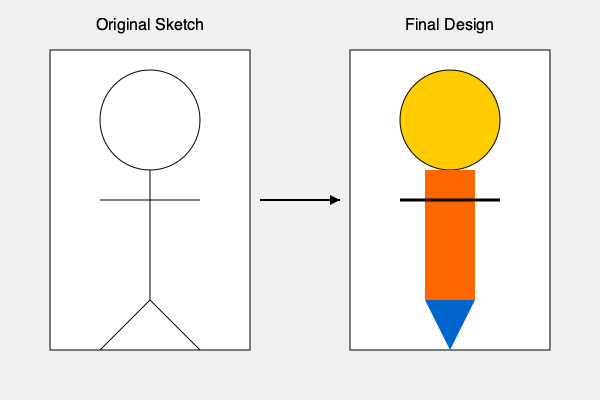In the character design evolution of FLCL, what significant changes can be observed between the original sketch and the final design of Haruko Haruhara's iconic Rickenbacker bass guitar? To answer this question, let's analyze the character design evolution of Haruko's Rickenbacker bass guitar in FLCL:

1. Shape: In the original sketch, the bass guitar is represented by a simple straight line. In the final design, it has evolved into a more defined rectangular shape with a distinct body.

2. Details: The original sketch lacks specific details, whereas the final design shows more intricate features:
   a. The body of the bass is colored orange (#ff6600), representing its iconic look.
   b. The headstock is now visible, colored blue (#0066cc), adding to the instrument's unique appearance.

3. Dimension: The original sketch is flat and two-dimensional. The final design gives a sense of depth and three-dimensionality to the bass guitar.

4. Proportion: In the final design, the bass guitar's size is more pronounced relative to Haruko's body, emphasizing its significance as a character prop and weapon.

5. Line weight: The original sketch uses uniform thin lines, while the final design employs varying line weights, particularly noticeable in the strings (represented by the thick black line).

These changes reflect the refinement process from concept to final character design, adding visual interest and personality to Haruko's signature instrument.
Answer: Added color, detail, dimension, and emphasis on the bass guitar's size and shape. 